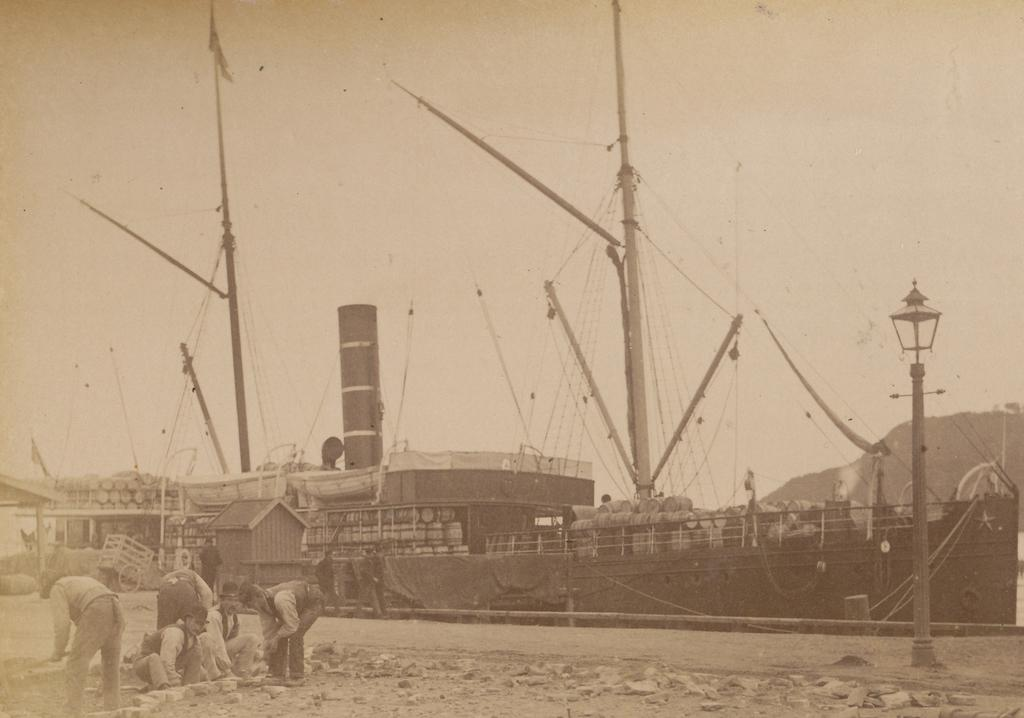What is the main subject of the image? There is a ship in the image. Can you describe the people in the image? There are people in the image, and some of them are wearing hats. What other objects can be seen in the image? There is a cart and stones on the ground in the image. How would you describe the weather in the image? The sky is cloudy in the image. What is the distribution of health among the people in the image? There is no information about the health of the people in the image, so it cannot be determined. 